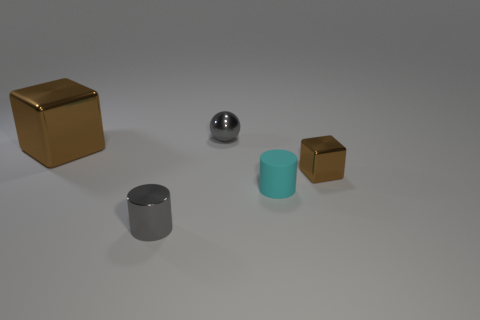If this scene were part of a physics puzzle, how might you describe the challenge involved? If this were a physics puzzle, the challenge could involve balancing the objects or calculating the volume of each object, given the diameter of the cylinders and the side length of the cubes. You might need to use principles of density and mass to solve a problem regarding buoyancy or stability if they were placed on a scale. 